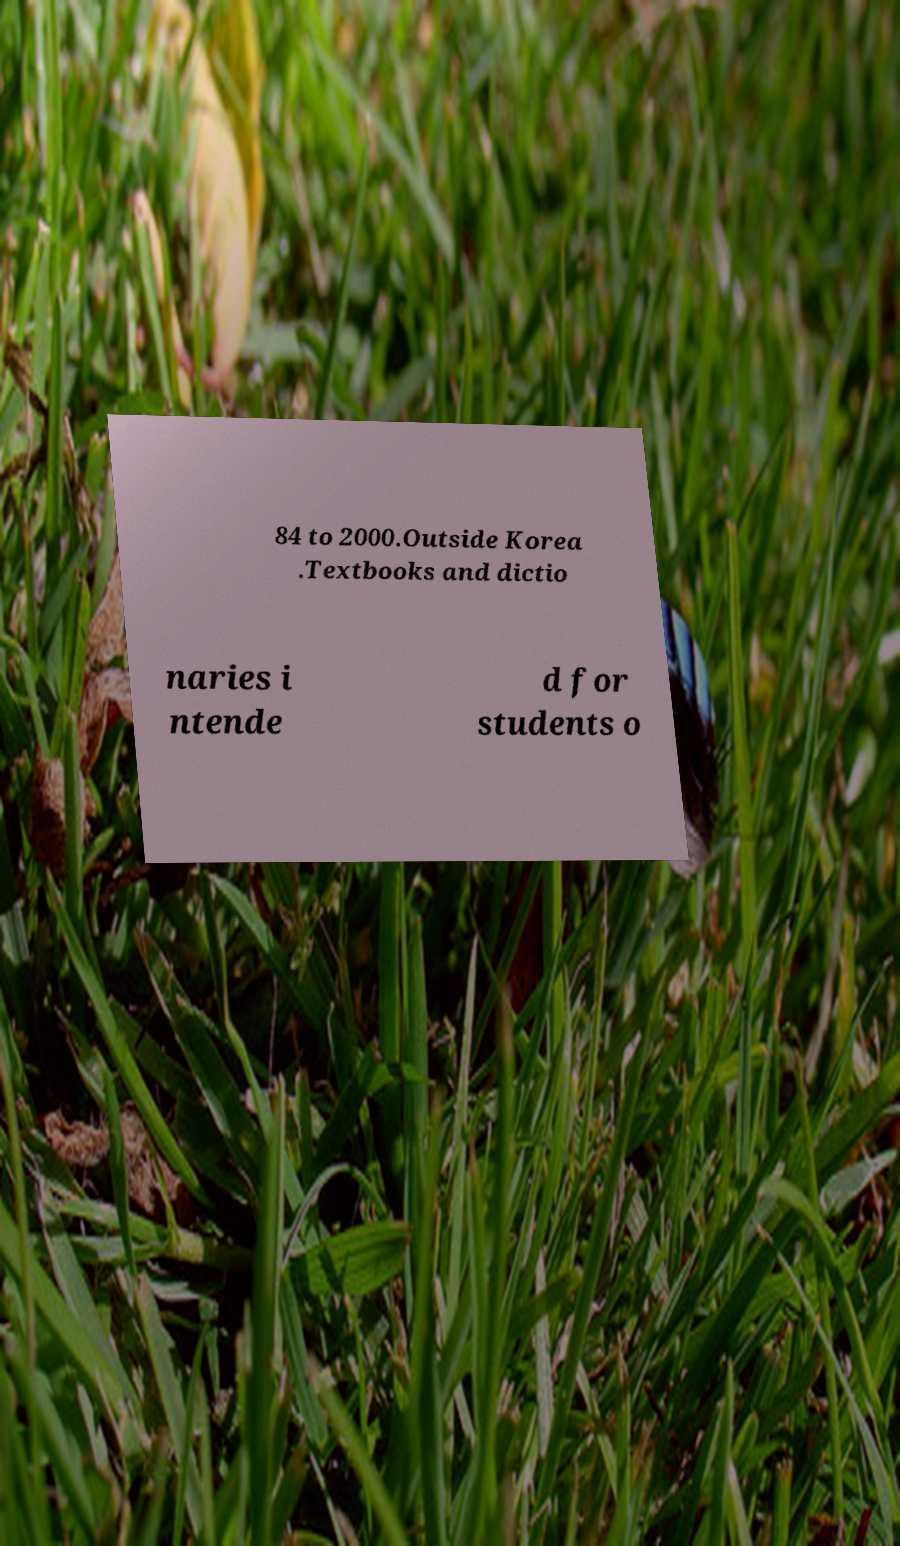I need the written content from this picture converted into text. Can you do that? 84 to 2000.Outside Korea .Textbooks and dictio naries i ntende d for students o 